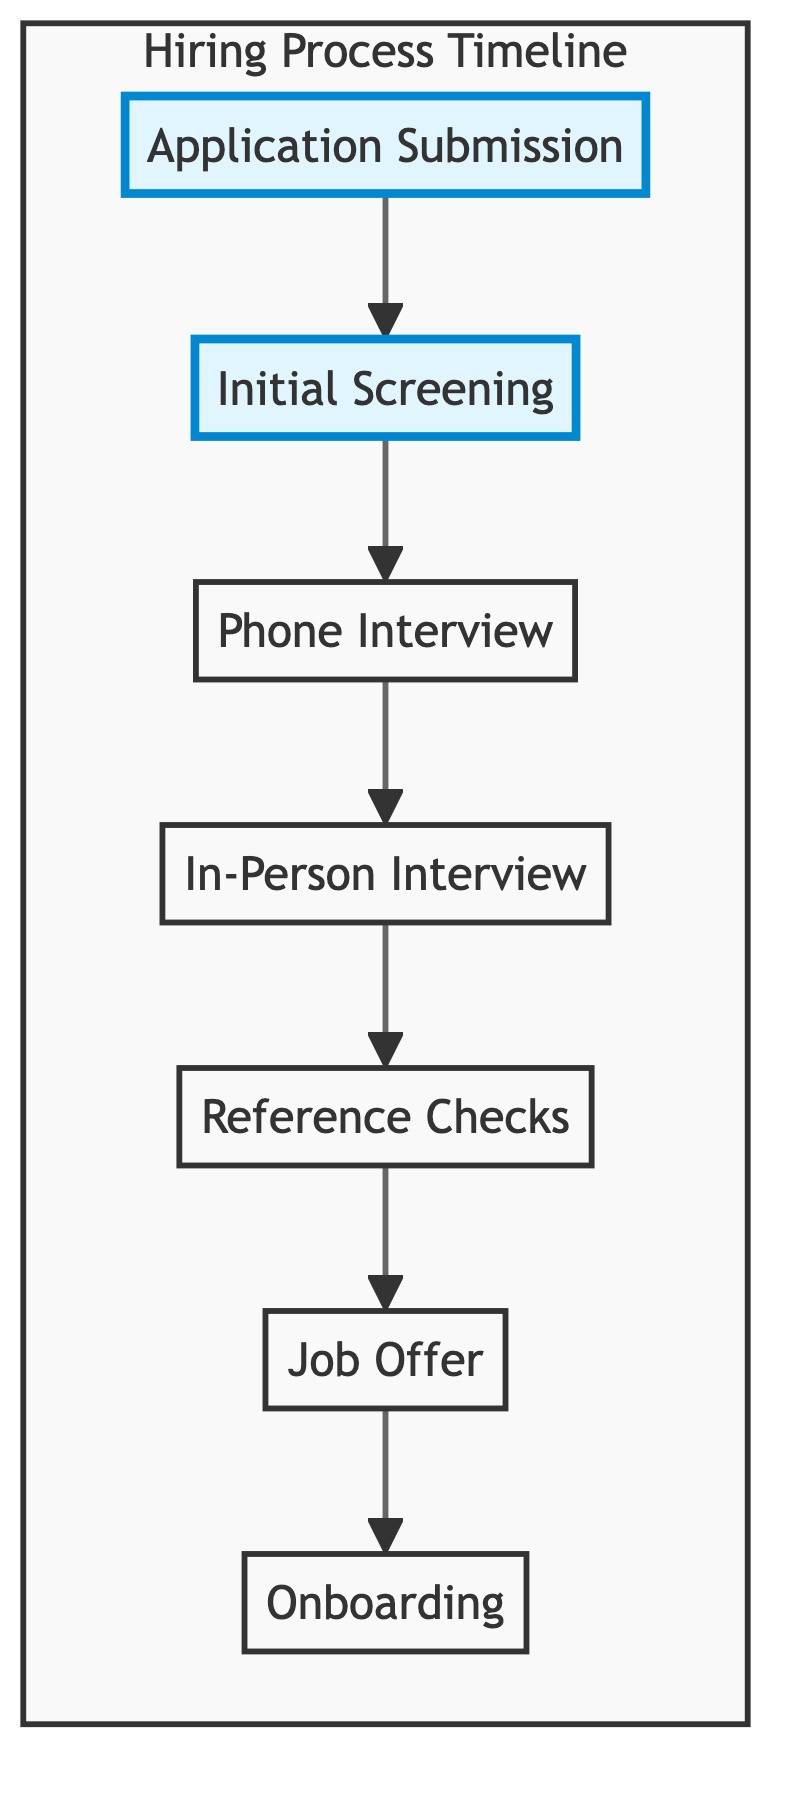What is the first stage of the hiring process? The first stage in the diagram is labeled "Application Submission," which directly shows the starting point of the hiring process.
Answer: Application Submission How many stages are in the hiring process? By counting the number of stages represented in the diagram from "Application Submission" to "Onboarding," we find there are a total of seven stages.
Answer: Seven What happens after the Phone Interview? In the diagram, the flow indicates that the next stage after "Phone Interview" is "In-Person Interview." Each stage leads to the next sequentially, showing their order in the process.
Answer: In-Person Interview What is the final stage of the hiring process timeline? The final stage, as depicted in the diagram, is "Onboarding," which signifies the completion of the hiring process.
Answer: Onboarding Which stage involves a formal job offer? According to the diagram, the stage where a formal job offer is made is labeled "Job Offer," showing a clear task within the hiring timeline.
Answer: Job Offer What is the relationship between Reference Checks and Job Offer? The relationship is sequential, as the diagram illustrates that "Reference Checks" must be completed before the "Job Offer" can be made. This indicates a clear dependency where one stage leads to the next.
Answer: Reference Checks precede Job Offer Which stage directly follows Initial Screening? The flowchart clearly shows that after the "Initial Screening" stage, the next step in the process is the "Phone Interview." This provides a direct sequence of activities.
Answer: Phone Interview How does the hiring process begin? The hiring process begins with the action of submitting an application and resume through the company's career portal, as indicated in the first node of the diagram.
Answer: By submitting an application and resume 